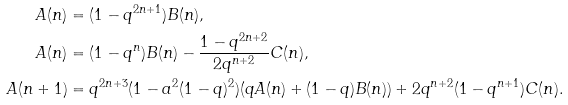Convert formula to latex. <formula><loc_0><loc_0><loc_500><loc_500>A ( n ) & = ( 1 - q ^ { 2 n + 1 } ) B ( n ) , \\ A ( n ) & = ( 1 - q ^ { n } ) B ( n ) - \frac { 1 - q ^ { 2 n + 2 } } { 2 q ^ { n + 2 } } C ( n ) , \\ A ( n + 1 ) & = q ^ { 2 n + 3 } ( 1 - a ^ { 2 } ( 1 - q ) ^ { 2 } ) ( q A ( n ) + ( 1 - q ) B ( n ) ) + 2 q ^ { n + 2 } ( 1 - q ^ { n + 1 } ) C ( n ) .</formula> 